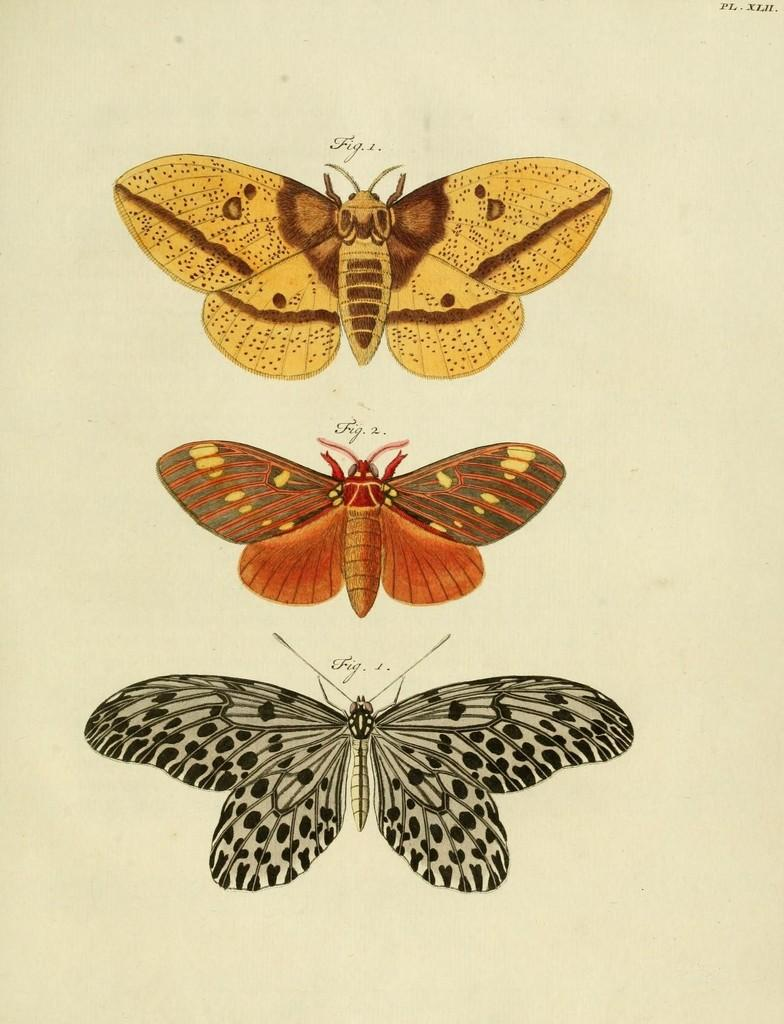How many pictures are present in the image? There are three pictures in the image. What is the common subject in all three pictures? Each picture contains a butterfly. Can you describe the butterflies in the pictures? The butterflies are of different colors. What type of sign can be seen in the image? There is no sign present in the image; it only contains three pictures of butterflies. Can you read any writing on the butterflies in the image? Butterflies do not have the ability to display writing, and there is no writing present on them in the image. 